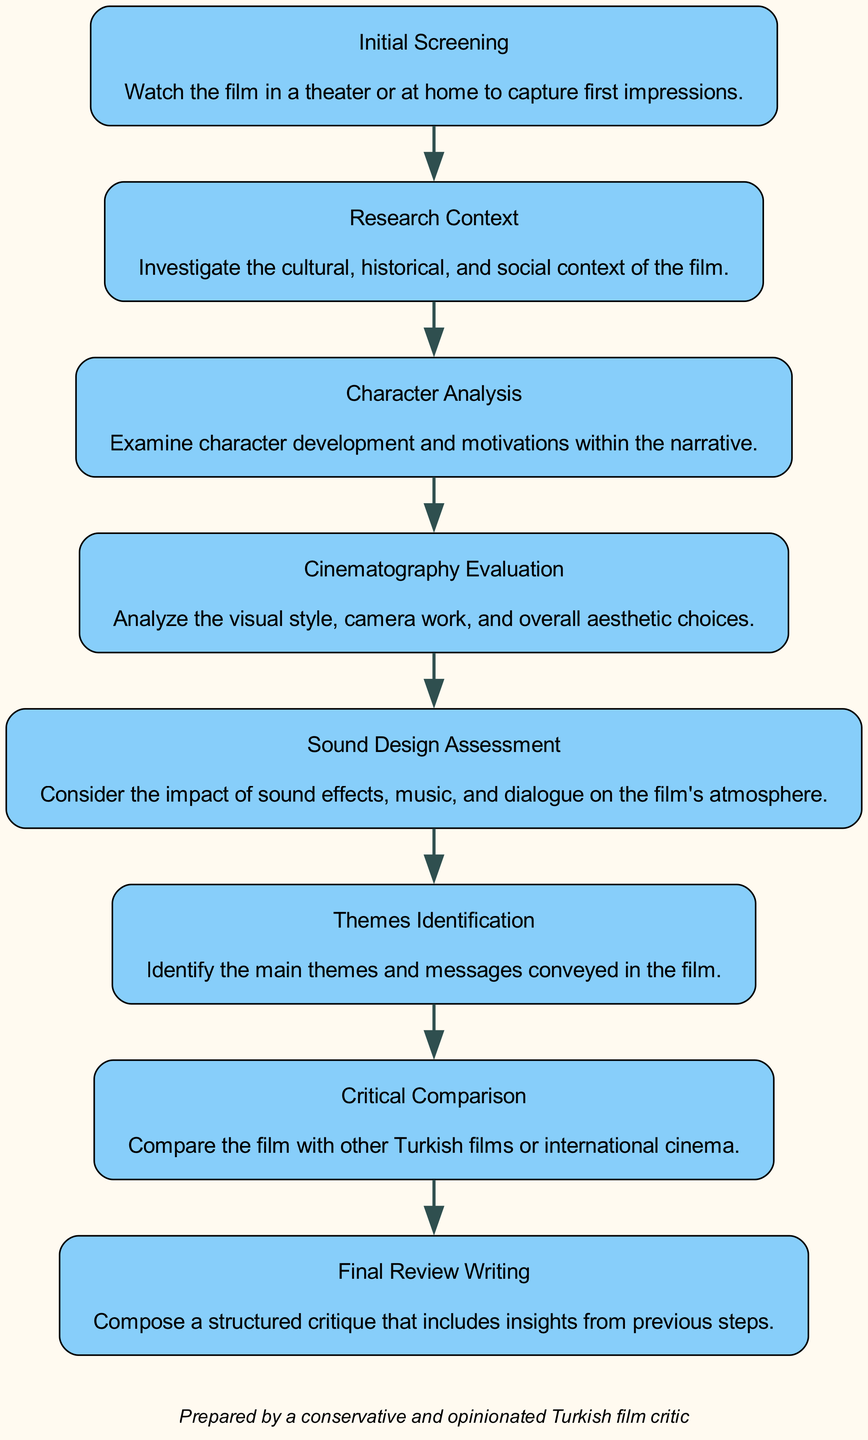What is the first step in the film review process? The first step listed in the diagram is "Initial Screening." This can be seen as the top node of the flowchart, indicating it is the starting point.
Answer: Initial Screening How many steps are there in total in the film review process? By counting the number of unique steps presented in the diagram, I find that there are eight steps in total.
Answer: 8 What comes after "Character Analysis"? Referring to the order of the steps in the flowchart, "Cinematography Evaluation" directly follows "Character Analysis"; it's the next step down in the flow.
Answer: Cinematography Evaluation What step involves understanding the film's cultural background? The step that relates to understanding the cultural background is "Research Context," as it specifically states the investigation of cultural, historical, and social context.
Answer: Research Context Which step is the last in the film review process? Looking at the flowchart, the last step is "Final Review Writing," as it appears at the bottom of the flow, following all previous steps.
Answer: Final Review Writing What is the focus of the "Sound Design Assessment" step? The "Sound Design Assessment" step focuses on the impact of sound effects, music, and dialogue on the film's atmosphere, as detailed in the description.
Answer: Sound effects, music, and dialogue How does "Critical Comparison" relate to other analyses in the process? "Critical Comparison" requires reviewing other Turkish films or international cinema, making it a step that synthesizes information from previous analyses and provides a broader perspective on the film being reviewed.
Answer: Broader perspective Which step immediately follows "Themes Identification"? According to the diagram layout, "Critical Comparison" follows "Themes Identification" in the sequence of the film review process.
Answer: Critical Comparison 